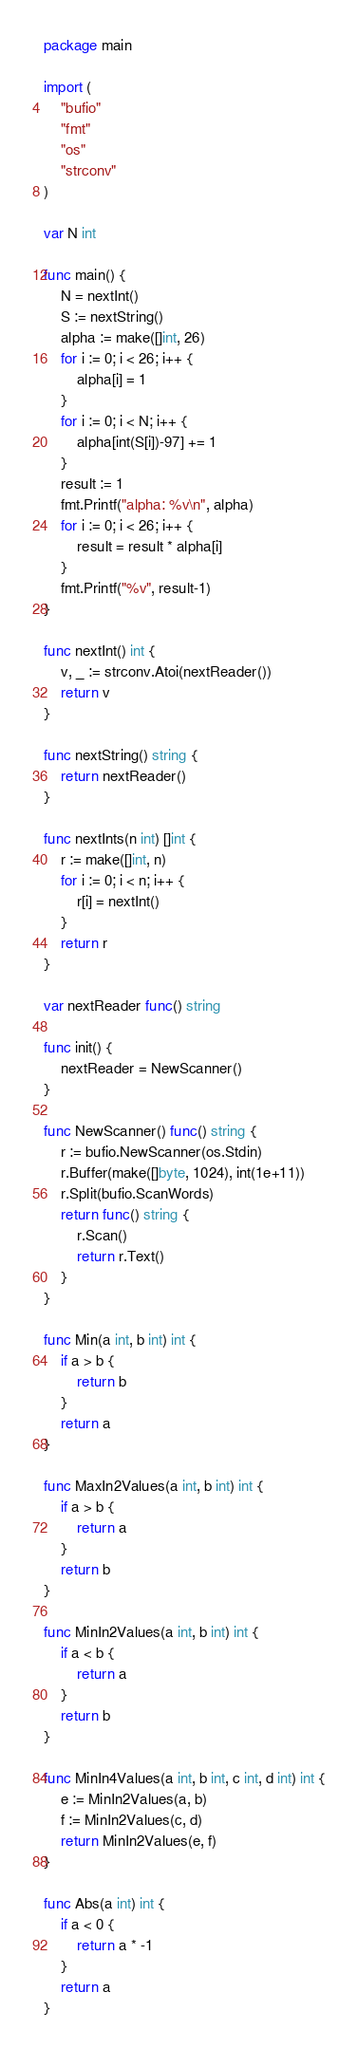Convert code to text. <code><loc_0><loc_0><loc_500><loc_500><_Go_>package main

import (
	"bufio"
	"fmt"
	"os"
	"strconv"
)

var N int

func main() {
	N = nextInt()
	S := nextString()
	alpha := make([]int, 26)
	for i := 0; i < 26; i++ {
		alpha[i] = 1
	}
	for i := 0; i < N; i++ {
		alpha[int(S[i])-97] += 1
	}
	result := 1
	fmt.Printf("alpha: %v\n", alpha)
	for i := 0; i < 26; i++ {
		result = result * alpha[i]
	}
	fmt.Printf("%v", result-1)
}

func nextInt() int {
	v, _ := strconv.Atoi(nextReader())
	return v
}

func nextString() string {
	return nextReader()
}

func nextInts(n int) []int {
	r := make([]int, n)
	for i := 0; i < n; i++ {
		r[i] = nextInt()
	}
	return r
}

var nextReader func() string

func init() {
	nextReader = NewScanner()
}

func NewScanner() func() string {
	r := bufio.NewScanner(os.Stdin)
	r.Buffer(make([]byte, 1024), int(1e+11))
	r.Split(bufio.ScanWords)
	return func() string {
		r.Scan()
		return r.Text()
	}
}

func Min(a int, b int) int {
	if a > b {
		return b
	}
	return a
}

func MaxIn2Values(a int, b int) int {
	if a > b {
		return a
	}
	return b
}

func MinIn2Values(a int, b int) int {
	if a < b {
		return a
	}
	return b
}

func MinIn4Values(a int, b int, c int, d int) int {
	e := MinIn2Values(a, b)
	f := MinIn2Values(c, d)
	return MinIn2Values(e, f)
}

func Abs(a int) int {
	if a < 0 {
		return a * -1
	}
	return a
}
</code> 